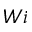Convert formula to latex. <formula><loc_0><loc_0><loc_500><loc_500>W i</formula> 